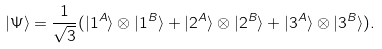<formula> <loc_0><loc_0><loc_500><loc_500>| \Psi \rangle = \frac { 1 } { \sqrt { 3 } } ( | 1 ^ { A } \rangle \otimes | 1 ^ { B } \rangle + | 2 ^ { A } \rangle \otimes | 2 ^ { B } \rangle + | 3 ^ { A } \rangle \otimes | 3 ^ { B } \rangle ) .</formula> 